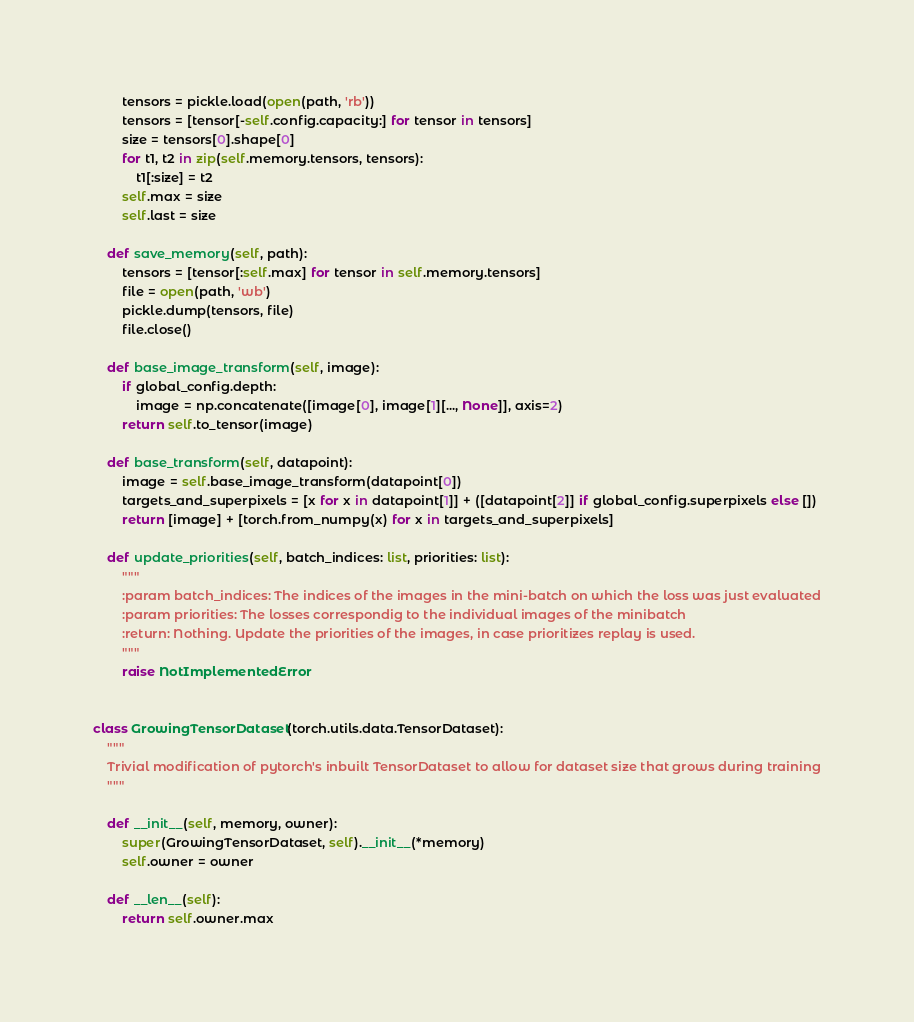Convert code to text. <code><loc_0><loc_0><loc_500><loc_500><_Python_>        tensors = pickle.load(open(path, 'rb'))
        tensors = [tensor[-self.config.capacity:] for tensor in tensors]
        size = tensors[0].shape[0]
        for t1, t2 in zip(self.memory.tensors, tensors):
            t1[:size] = t2
        self.max = size
        self.last = size

    def save_memory(self, path):
        tensors = [tensor[:self.max] for tensor in self.memory.tensors]
        file = open(path, 'wb')
        pickle.dump(tensors, file)
        file.close()

    def base_image_transform(self, image):
        if global_config.depth:
            image = np.concatenate([image[0], image[1][..., None]], axis=2)
        return self.to_tensor(image)

    def base_transform(self, datapoint):
        image = self.base_image_transform(datapoint[0])
        targets_and_superpixels = [x for x in datapoint[1]] + ([datapoint[2]] if global_config.superpixels else [])
        return [image] + [torch.from_numpy(x) for x in targets_and_superpixels]

    def update_priorities(self, batch_indices: list, priorities: list):
        """
        :param batch_indices: The indices of the images in the mini-batch on which the loss was just evaluated
        :param priorities: The losses correspondig to the individual images of the minibatch
        :return: Nothing. Update the priorities of the images, in case prioritizes replay is used.
        """
        raise NotImplementedError


class GrowingTensorDataset(torch.utils.data.TensorDataset):
    """
    Trivial modification of pytorch's inbuilt TensorDataset to allow for dataset size that grows during training
    """

    def __init__(self, memory, owner):
        super(GrowingTensorDataset, self).__init__(*memory)
        self.owner = owner

    def __len__(self):
        return self.owner.max
</code> 